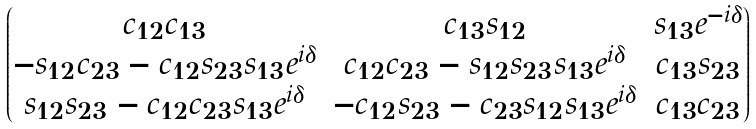<formula> <loc_0><loc_0><loc_500><loc_500>\begin{pmatrix} c _ { 1 2 } c _ { 1 3 } & c _ { 1 3 } s _ { 1 2 } & s _ { 1 3 } e ^ { - i \delta } \\ - s _ { 1 2 } c _ { 2 3 } - c _ { 1 2 } s _ { 2 3 } s _ { 1 3 } e ^ { i \delta } & c _ { 1 2 } c _ { 2 3 } - s _ { 1 2 } s _ { 2 3 } s _ { 1 3 } e ^ { i \delta } & c _ { 1 3 } s _ { 2 3 } \\ s _ { 1 2 } s _ { 2 3 } - c _ { 1 2 } c _ { 2 3 } s _ { 1 3 } e ^ { i \delta } & - c _ { 1 2 } s _ { 2 3 } - c _ { 2 3 } s _ { 1 2 } s _ { 1 3 } e ^ { i \delta } & c _ { 1 3 } c _ { 2 3 } \end{pmatrix}</formula> 